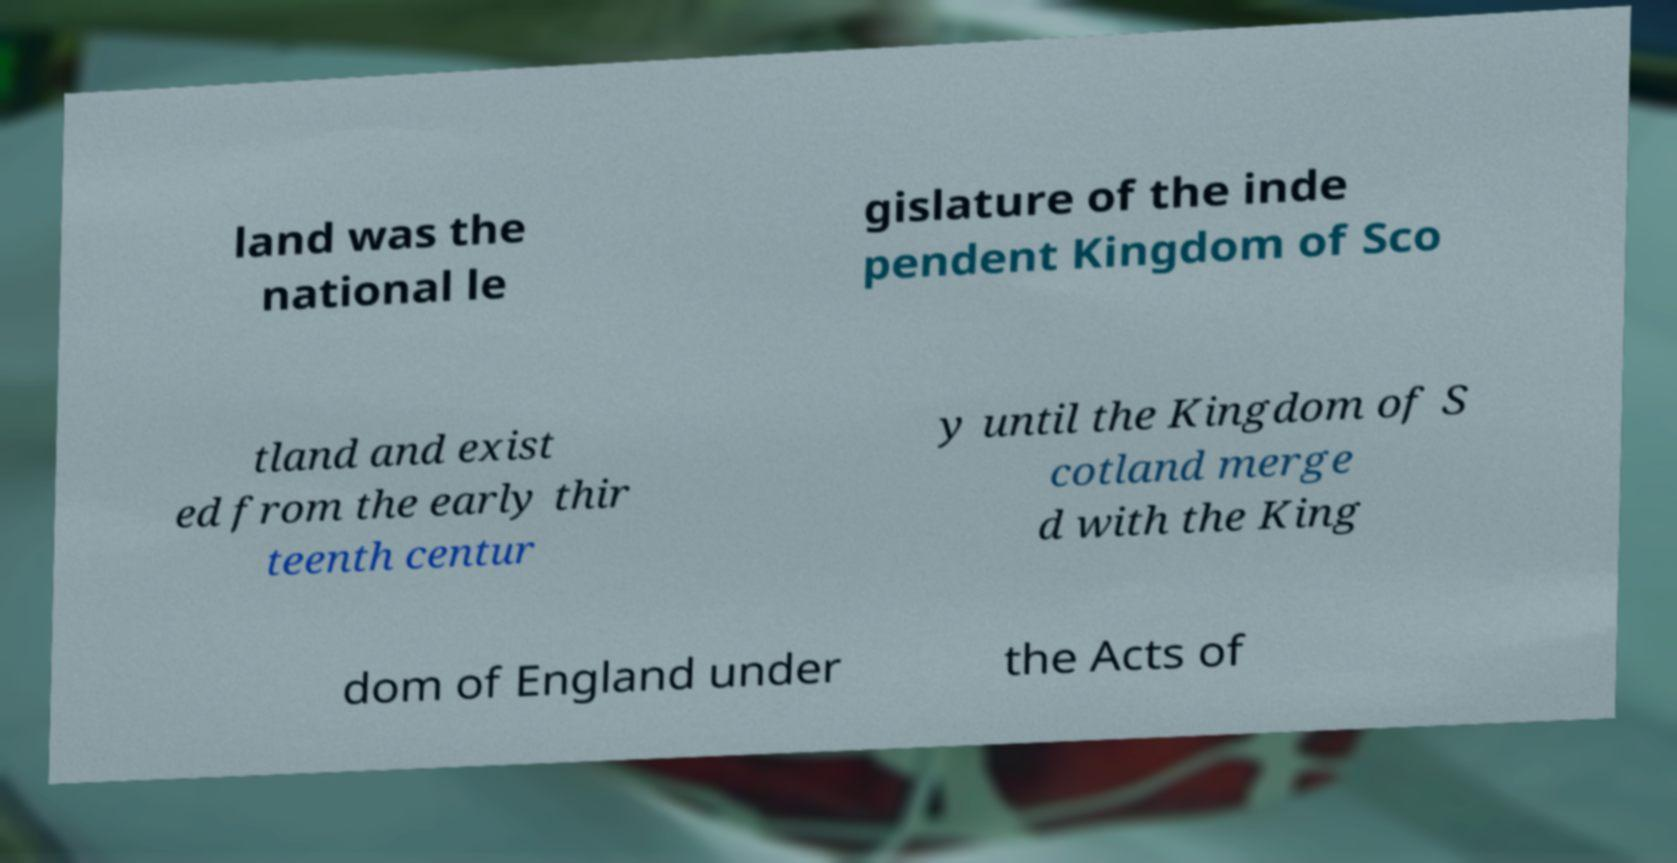For documentation purposes, I need the text within this image transcribed. Could you provide that? land was the national le gislature of the inde pendent Kingdom of Sco tland and exist ed from the early thir teenth centur y until the Kingdom of S cotland merge d with the King dom of England under the Acts of 